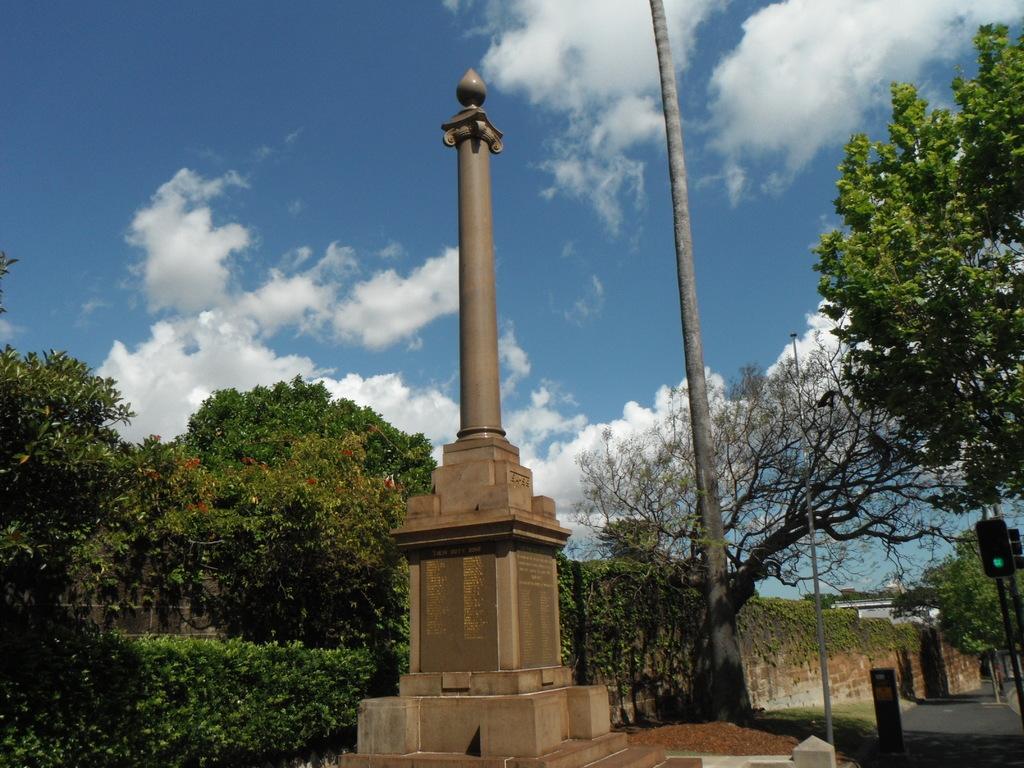Describe this image in one or two sentences. In front of the picture, we see a monument. Behind that, we see a pole. There are trees and buildings in the background. In the right bottom of the picture, we see the road and traffic signals. At the top of the picture, we see the sky and the clouds. 